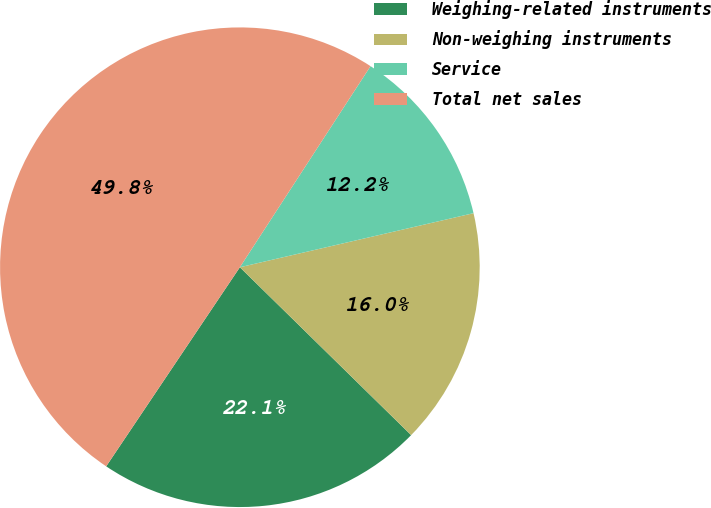Convert chart. <chart><loc_0><loc_0><loc_500><loc_500><pie_chart><fcel>Weighing-related instruments<fcel>Non-weighing instruments<fcel>Service<fcel>Total net sales<nl><fcel>22.07%<fcel>15.96%<fcel>12.21%<fcel>49.76%<nl></chart> 